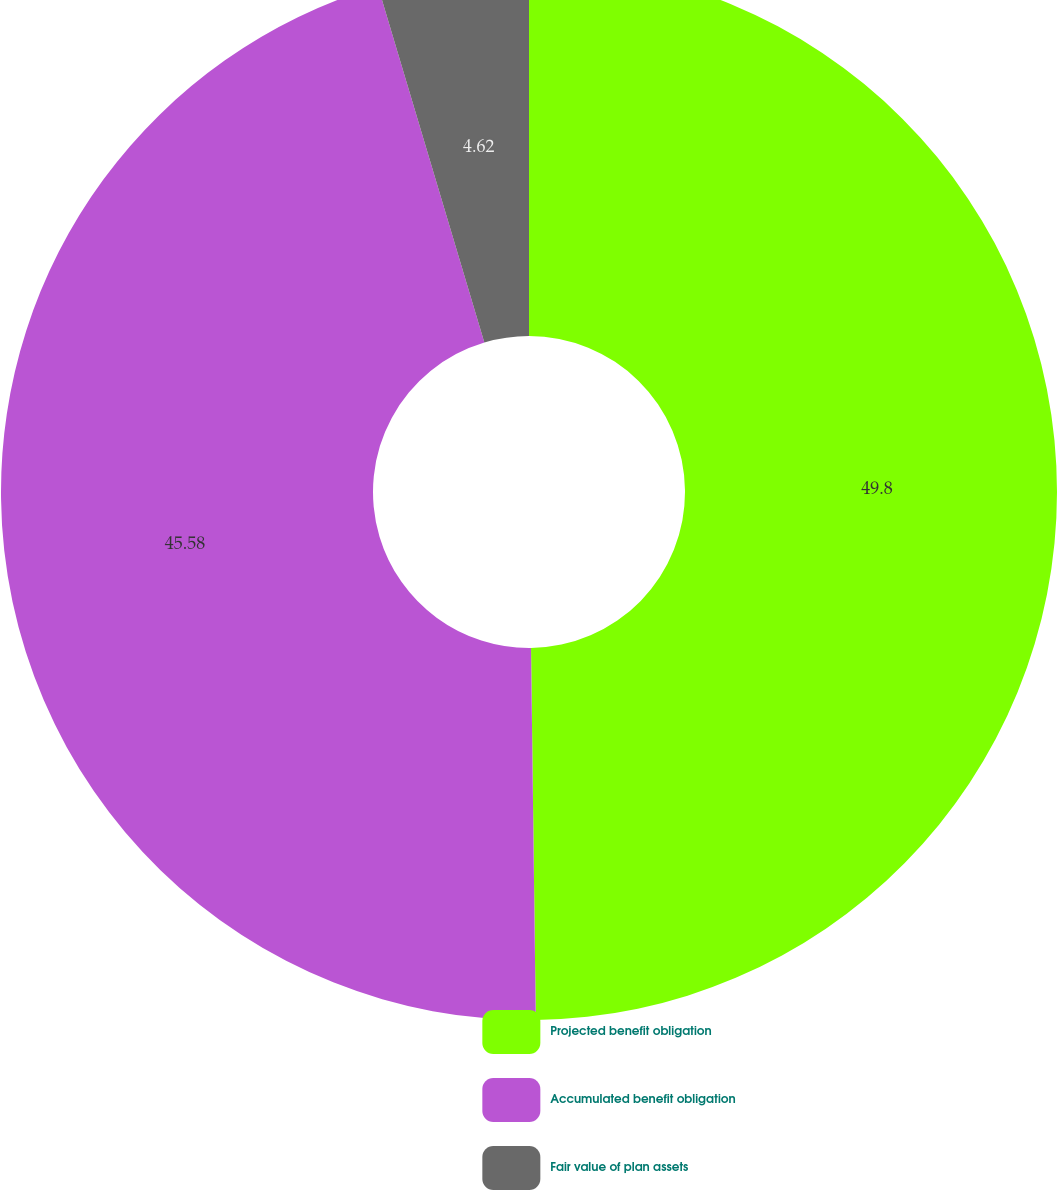<chart> <loc_0><loc_0><loc_500><loc_500><pie_chart><fcel>Projected benefit obligation<fcel>Accumulated benefit obligation<fcel>Fair value of plan assets<nl><fcel>49.79%<fcel>45.58%<fcel>4.62%<nl></chart> 